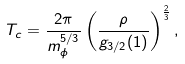Convert formula to latex. <formula><loc_0><loc_0><loc_500><loc_500>T _ { c } = \frac { 2 \pi } { m _ { \phi } ^ { 5 / 3 } } \left ( \frac { \rho } { g _ { 3 / 2 } ( 1 ) } \right ) ^ { \frac { 2 } { 3 } } ,</formula> 